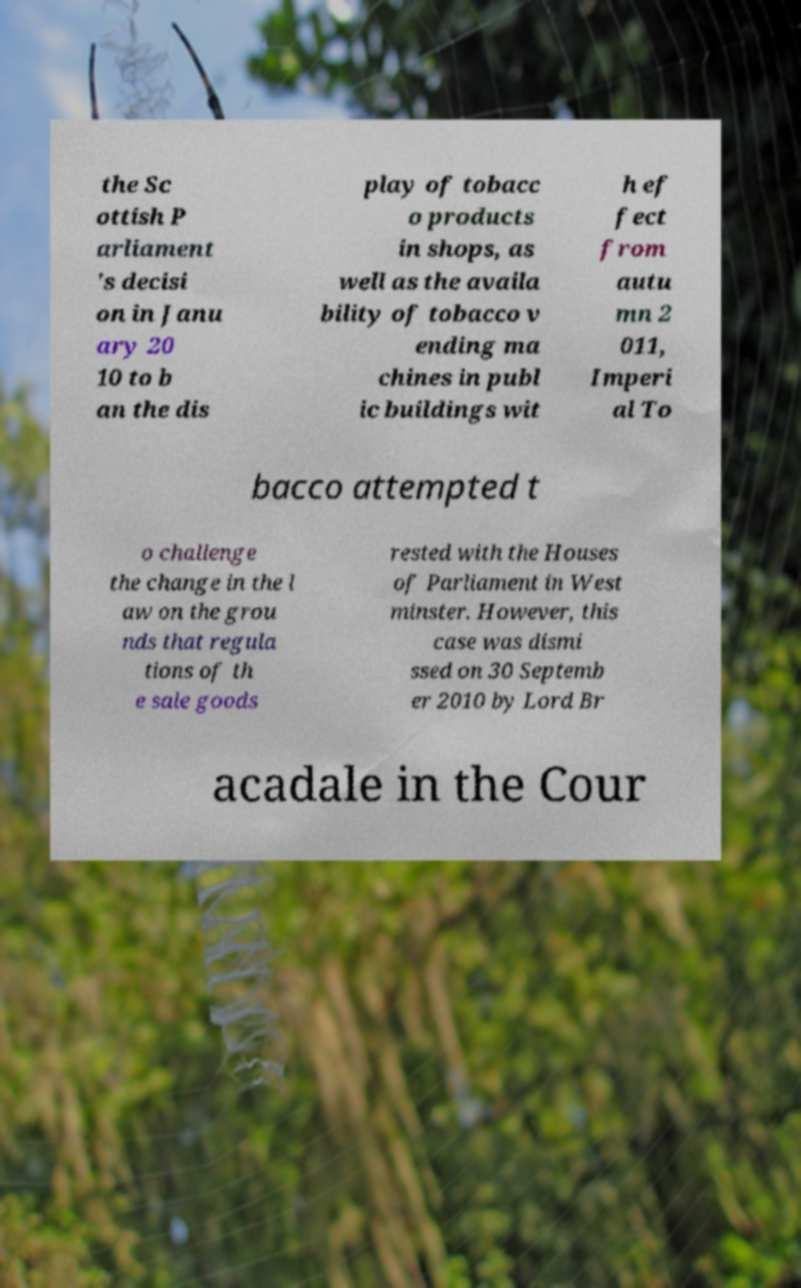Please read and relay the text visible in this image. What does it say? the Sc ottish P arliament 's decisi on in Janu ary 20 10 to b an the dis play of tobacc o products in shops, as well as the availa bility of tobacco v ending ma chines in publ ic buildings wit h ef fect from autu mn 2 011, Imperi al To bacco attempted t o challenge the change in the l aw on the grou nds that regula tions of th e sale goods rested with the Houses of Parliament in West minster. However, this case was dismi ssed on 30 Septemb er 2010 by Lord Br acadale in the Cour 